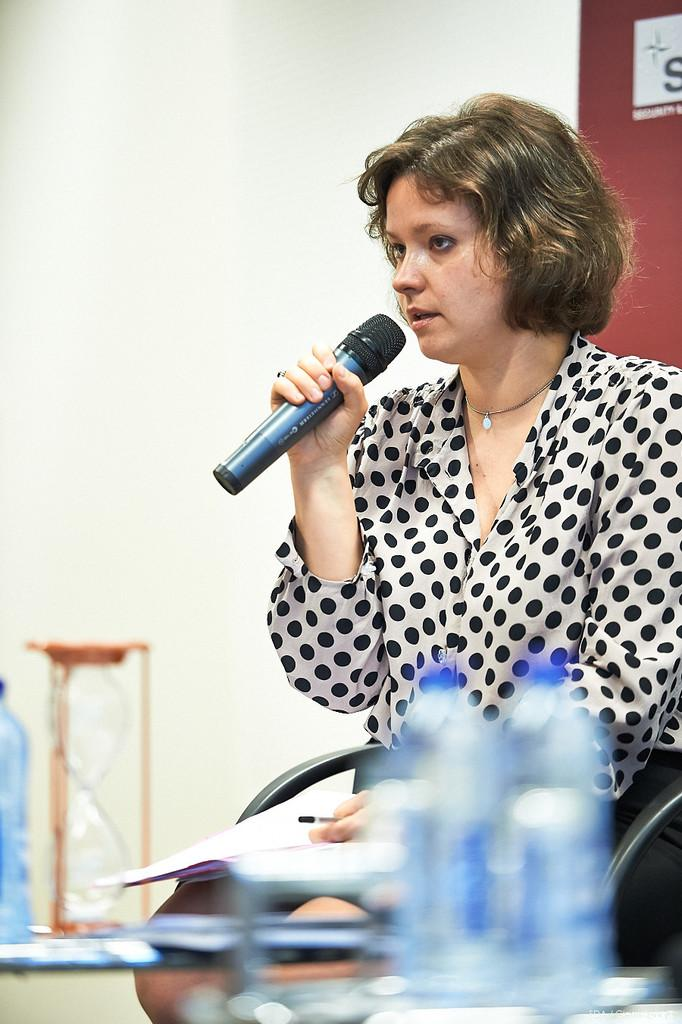Who is the main subject in the image? There is a woman in the image. What is the woman doing in the image? The woman is sitting in a chair and speaking into a microphone. What is the woman wearing in the image? The woman is wearing a black and white dress. Is the woman bleeding from her nose in the image? No, there is no indication of blood or any injury in the image. 